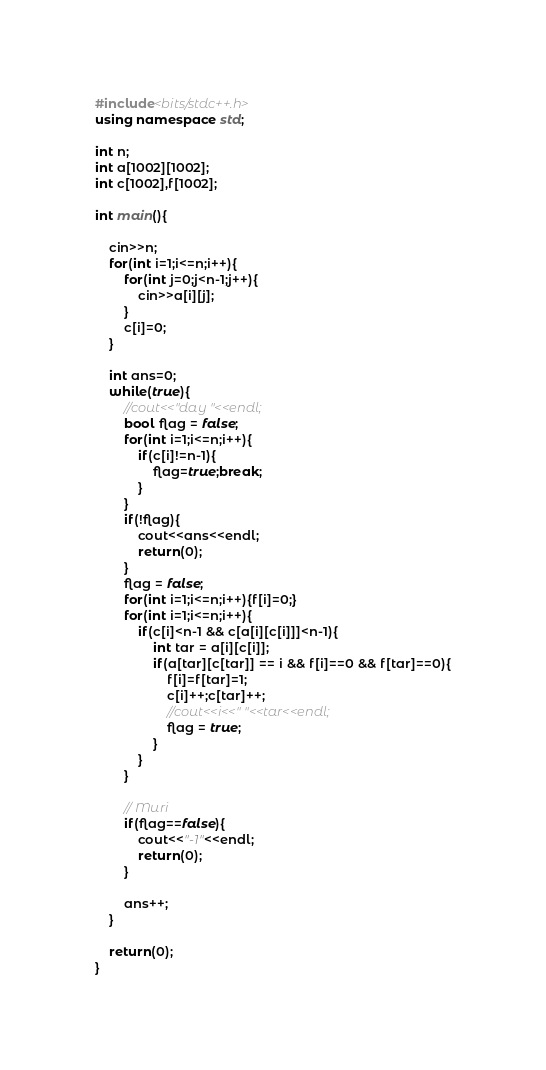<code> <loc_0><loc_0><loc_500><loc_500><_C++_>#include<bits/stdc++.h>
using namespace std;

int n;
int a[1002][1002];
int c[1002],f[1002];

int main(){
	
	cin>>n;
	for(int i=1;i<=n;i++){
		for(int j=0;j<n-1;j++){
			cin>>a[i][j];
		}
		c[i]=0;
	}

	int ans=0;
	while(true){
		//cout<<"day "<<endl;
		bool flag = false;
		for(int i=1;i<=n;i++){
			if(c[i]!=n-1){
				flag=true;break;
			}
		}
		if(!flag){
			cout<<ans<<endl;
			return(0);
		}
		flag = false;
		for(int i=1;i<=n;i++){f[i]=0;}
		for(int i=1;i<=n;i++){
			if(c[i]<n-1 && c[a[i][c[i]]]<n-1){
				int tar = a[i][c[i]];
				if(a[tar][c[tar]] == i && f[i]==0 && f[tar]==0){
					f[i]=f[tar]=1;
					c[i]++;c[tar]++;
					//cout<<i<<" "<<tar<<endl;
					flag = true;
				}
			}
		}

		// Muri
		if(flag==false){
			cout<<"-1"<<endl;
			return(0);
		}

		ans++;
	}

	return(0);
}</code> 